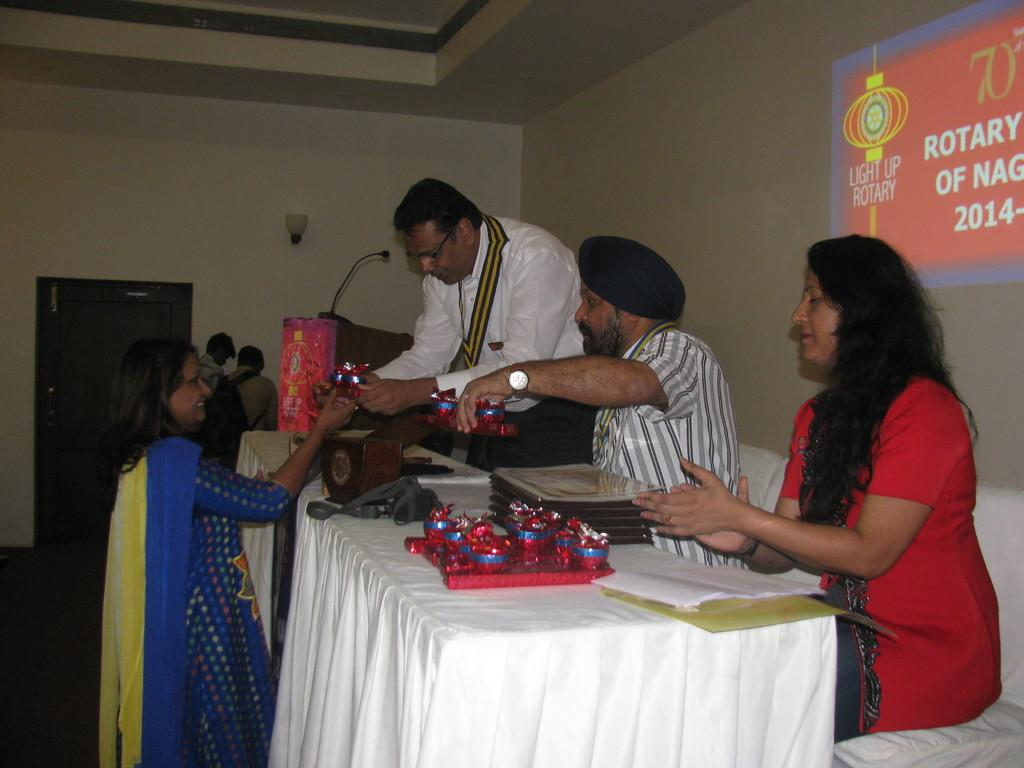How many people are present in the room? There are many people in the room. What positions are two of the people in? Two people are sitting. What positions are two other people in? Two people are standing. What object is in front of the people? There is a table in front of the people. Can you see any ants crawling on the table in the image? There is no mention of ants in the image, so we cannot determine if any are present. 